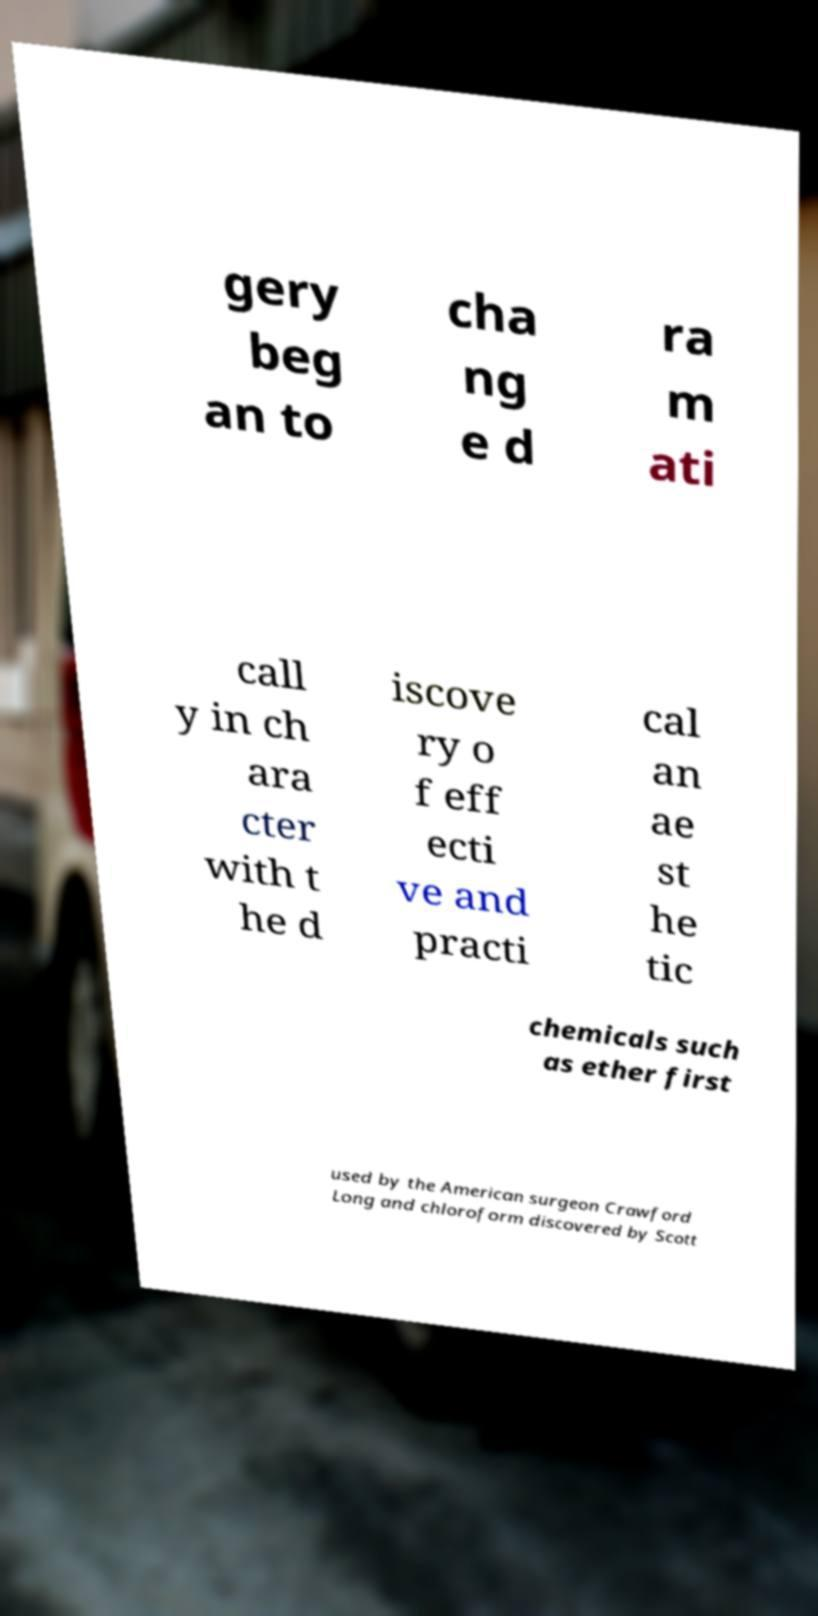Could you assist in decoding the text presented in this image and type it out clearly? gery beg an to cha ng e d ra m ati call y in ch ara cter with t he d iscove ry o f eff ecti ve and practi cal an ae st he tic chemicals such as ether first used by the American surgeon Crawford Long and chloroform discovered by Scott 